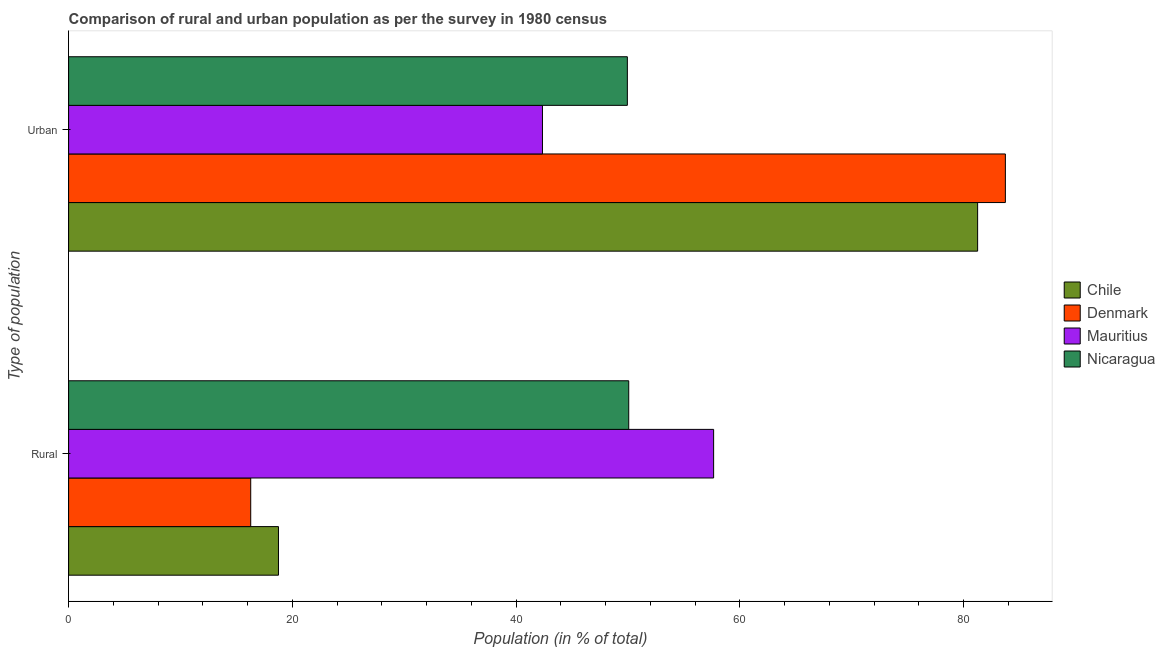How many different coloured bars are there?
Make the answer very short. 4. Are the number of bars per tick equal to the number of legend labels?
Ensure brevity in your answer.  Yes. How many bars are there on the 1st tick from the top?
Make the answer very short. 4. How many bars are there on the 1st tick from the bottom?
Keep it short and to the point. 4. What is the label of the 2nd group of bars from the top?
Offer a terse response. Rural. What is the rural population in Nicaragua?
Your answer should be very brief. 50.06. Across all countries, what is the maximum rural population?
Offer a terse response. 57.65. Across all countries, what is the minimum urban population?
Give a very brief answer. 42.35. In which country was the urban population minimum?
Provide a short and direct response. Mauritius. What is the total rural population in the graph?
Your answer should be very brief. 142.75. What is the difference between the urban population in Chile and that in Mauritius?
Offer a terse response. 38.89. What is the difference between the rural population in Nicaragua and the urban population in Denmark?
Keep it short and to the point. -33.66. What is the average rural population per country?
Provide a succinct answer. 35.69. What is the difference between the urban population and rural population in Nicaragua?
Give a very brief answer. -0.12. In how many countries, is the rural population greater than 4 %?
Your answer should be compact. 4. What is the ratio of the rural population in Chile to that in Mauritius?
Make the answer very short. 0.33. What does the 1st bar from the top in Rural represents?
Make the answer very short. Nicaragua. What does the 4th bar from the bottom in Urban represents?
Ensure brevity in your answer.  Nicaragua. What is the difference between two consecutive major ticks on the X-axis?
Your answer should be compact. 20. Are the values on the major ticks of X-axis written in scientific E-notation?
Offer a very short reply. No. Does the graph contain any zero values?
Provide a short and direct response. No. Does the graph contain grids?
Provide a succinct answer. No. Where does the legend appear in the graph?
Your response must be concise. Center right. How many legend labels are there?
Keep it short and to the point. 4. How are the legend labels stacked?
Your answer should be compact. Vertical. What is the title of the graph?
Offer a very short reply. Comparison of rural and urban population as per the survey in 1980 census. What is the label or title of the X-axis?
Give a very brief answer. Population (in % of total). What is the label or title of the Y-axis?
Give a very brief answer. Type of population. What is the Population (in % of total) in Chile in Rural?
Ensure brevity in your answer.  18.76. What is the Population (in % of total) of Denmark in Rural?
Give a very brief answer. 16.28. What is the Population (in % of total) in Mauritius in Rural?
Give a very brief answer. 57.65. What is the Population (in % of total) of Nicaragua in Rural?
Offer a terse response. 50.06. What is the Population (in % of total) in Chile in Urban?
Provide a succinct answer. 81.24. What is the Population (in % of total) in Denmark in Urban?
Your answer should be very brief. 83.72. What is the Population (in % of total) of Mauritius in Urban?
Offer a very short reply. 42.35. What is the Population (in % of total) in Nicaragua in Urban?
Your answer should be compact. 49.94. Across all Type of population, what is the maximum Population (in % of total) in Chile?
Offer a very short reply. 81.24. Across all Type of population, what is the maximum Population (in % of total) of Denmark?
Your answer should be compact. 83.72. Across all Type of population, what is the maximum Population (in % of total) in Mauritius?
Give a very brief answer. 57.65. Across all Type of population, what is the maximum Population (in % of total) of Nicaragua?
Your response must be concise. 50.06. Across all Type of population, what is the minimum Population (in % of total) of Chile?
Your answer should be very brief. 18.76. Across all Type of population, what is the minimum Population (in % of total) of Denmark?
Provide a succinct answer. 16.28. Across all Type of population, what is the minimum Population (in % of total) of Mauritius?
Your answer should be very brief. 42.35. Across all Type of population, what is the minimum Population (in % of total) of Nicaragua?
Your answer should be very brief. 49.94. What is the total Population (in % of total) of Denmark in the graph?
Your answer should be very brief. 100. What is the total Population (in % of total) of Mauritius in the graph?
Keep it short and to the point. 100. What is the total Population (in % of total) of Nicaragua in the graph?
Make the answer very short. 100. What is the difference between the Population (in % of total) of Chile in Rural and that in Urban?
Provide a succinct answer. -62.49. What is the difference between the Population (in % of total) of Denmark in Rural and that in Urban?
Keep it short and to the point. -67.45. What is the difference between the Population (in % of total) of Mauritius in Rural and that in Urban?
Offer a very short reply. 15.3. What is the difference between the Population (in % of total) of Nicaragua in Rural and that in Urban?
Your answer should be compact. 0.12. What is the difference between the Population (in % of total) of Chile in Rural and the Population (in % of total) of Denmark in Urban?
Provide a short and direct response. -64.97. What is the difference between the Population (in % of total) in Chile in Rural and the Population (in % of total) in Mauritius in Urban?
Offer a terse response. -23.59. What is the difference between the Population (in % of total) in Chile in Rural and the Population (in % of total) in Nicaragua in Urban?
Offer a very short reply. -31.18. What is the difference between the Population (in % of total) of Denmark in Rural and the Population (in % of total) of Mauritius in Urban?
Make the answer very short. -26.07. What is the difference between the Population (in % of total) of Denmark in Rural and the Population (in % of total) of Nicaragua in Urban?
Provide a succinct answer. -33.66. What is the difference between the Population (in % of total) of Mauritius in Rural and the Population (in % of total) of Nicaragua in Urban?
Your answer should be very brief. 7.71. What is the average Population (in % of total) of Chile per Type of population?
Your answer should be compact. 50. What is the average Population (in % of total) in Denmark per Type of population?
Provide a short and direct response. 50. What is the difference between the Population (in % of total) in Chile and Population (in % of total) in Denmark in Rural?
Your response must be concise. 2.48. What is the difference between the Population (in % of total) in Chile and Population (in % of total) in Mauritius in Rural?
Keep it short and to the point. -38.89. What is the difference between the Population (in % of total) of Chile and Population (in % of total) of Nicaragua in Rural?
Provide a short and direct response. -31.3. What is the difference between the Population (in % of total) in Denmark and Population (in % of total) in Mauritius in Rural?
Your answer should be compact. -41.37. What is the difference between the Population (in % of total) of Denmark and Population (in % of total) of Nicaragua in Rural?
Provide a succinct answer. -33.78. What is the difference between the Population (in % of total) of Mauritius and Population (in % of total) of Nicaragua in Rural?
Your answer should be compact. 7.59. What is the difference between the Population (in % of total) of Chile and Population (in % of total) of Denmark in Urban?
Your answer should be very brief. -2.48. What is the difference between the Population (in % of total) in Chile and Population (in % of total) in Mauritius in Urban?
Make the answer very short. 38.89. What is the difference between the Population (in % of total) in Chile and Population (in % of total) in Nicaragua in Urban?
Your answer should be compact. 31.3. What is the difference between the Population (in % of total) of Denmark and Population (in % of total) of Mauritius in Urban?
Ensure brevity in your answer.  41.37. What is the difference between the Population (in % of total) in Denmark and Population (in % of total) in Nicaragua in Urban?
Make the answer very short. 33.78. What is the difference between the Population (in % of total) in Mauritius and Population (in % of total) in Nicaragua in Urban?
Keep it short and to the point. -7.59. What is the ratio of the Population (in % of total) in Chile in Rural to that in Urban?
Provide a succinct answer. 0.23. What is the ratio of the Population (in % of total) in Denmark in Rural to that in Urban?
Your response must be concise. 0.19. What is the ratio of the Population (in % of total) of Mauritius in Rural to that in Urban?
Offer a very short reply. 1.36. What is the ratio of the Population (in % of total) in Nicaragua in Rural to that in Urban?
Make the answer very short. 1. What is the difference between the highest and the second highest Population (in % of total) in Chile?
Ensure brevity in your answer.  62.49. What is the difference between the highest and the second highest Population (in % of total) of Denmark?
Make the answer very short. 67.45. What is the difference between the highest and the second highest Population (in % of total) in Mauritius?
Your answer should be very brief. 15.3. What is the difference between the highest and the second highest Population (in % of total) in Nicaragua?
Provide a short and direct response. 0.12. What is the difference between the highest and the lowest Population (in % of total) in Chile?
Your answer should be very brief. 62.49. What is the difference between the highest and the lowest Population (in % of total) in Denmark?
Make the answer very short. 67.45. What is the difference between the highest and the lowest Population (in % of total) in Mauritius?
Your answer should be compact. 15.3. What is the difference between the highest and the lowest Population (in % of total) in Nicaragua?
Give a very brief answer. 0.12. 